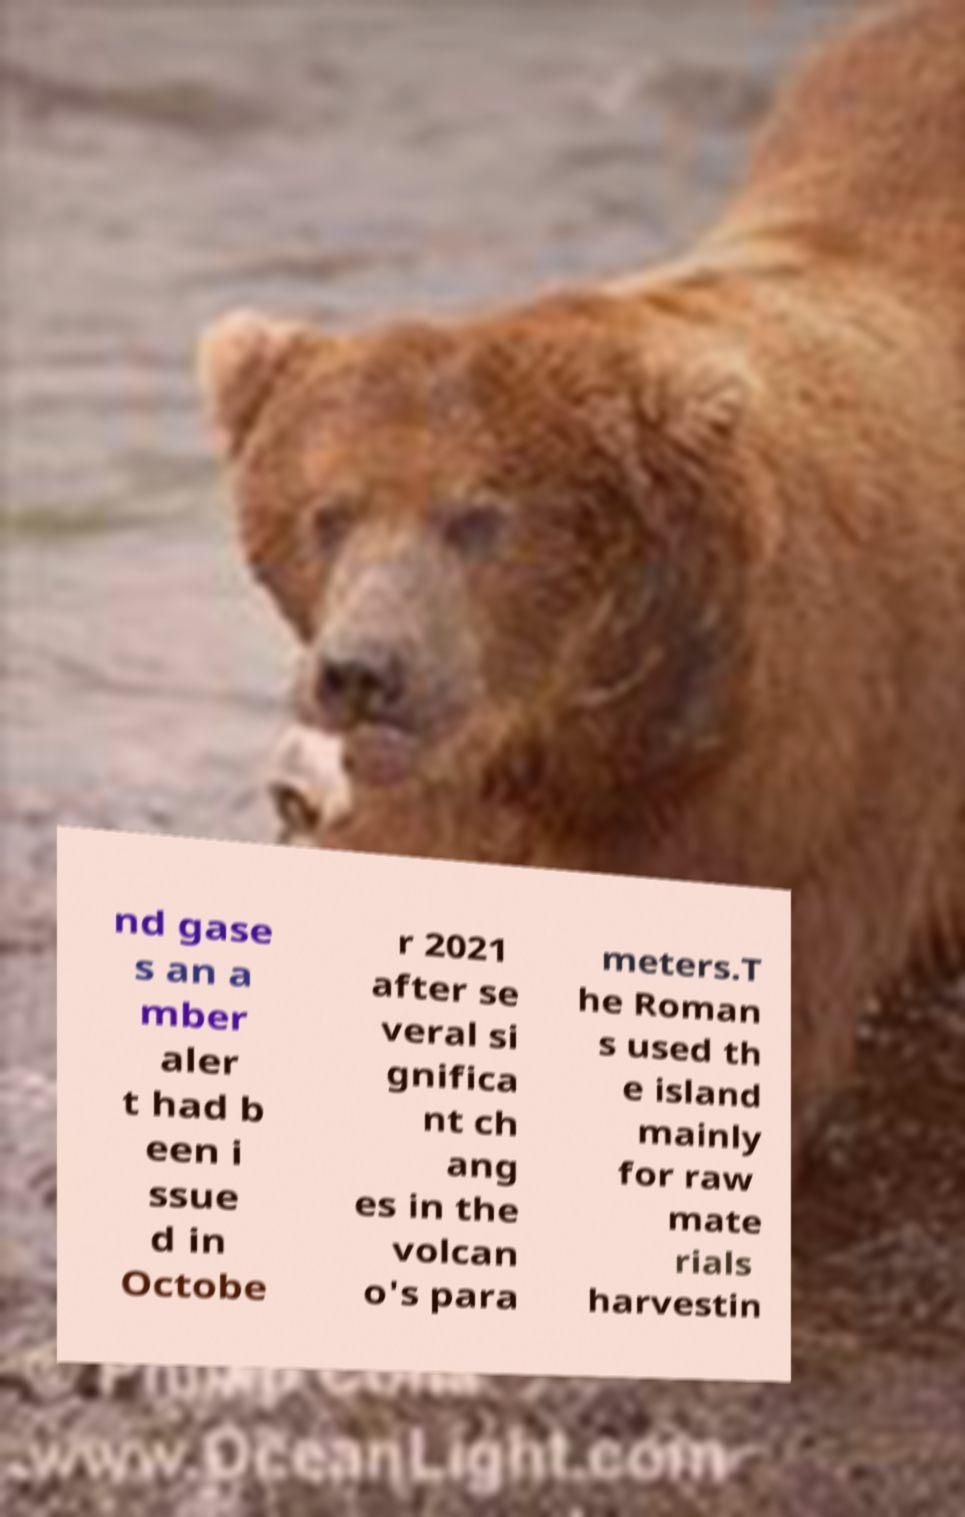Can you read and provide the text displayed in the image?This photo seems to have some interesting text. Can you extract and type it out for me? nd gase s an a mber aler t had b een i ssue d in Octobe r 2021 after se veral si gnifica nt ch ang es in the volcan o's para meters.T he Roman s used th e island mainly for raw mate rials harvestin 